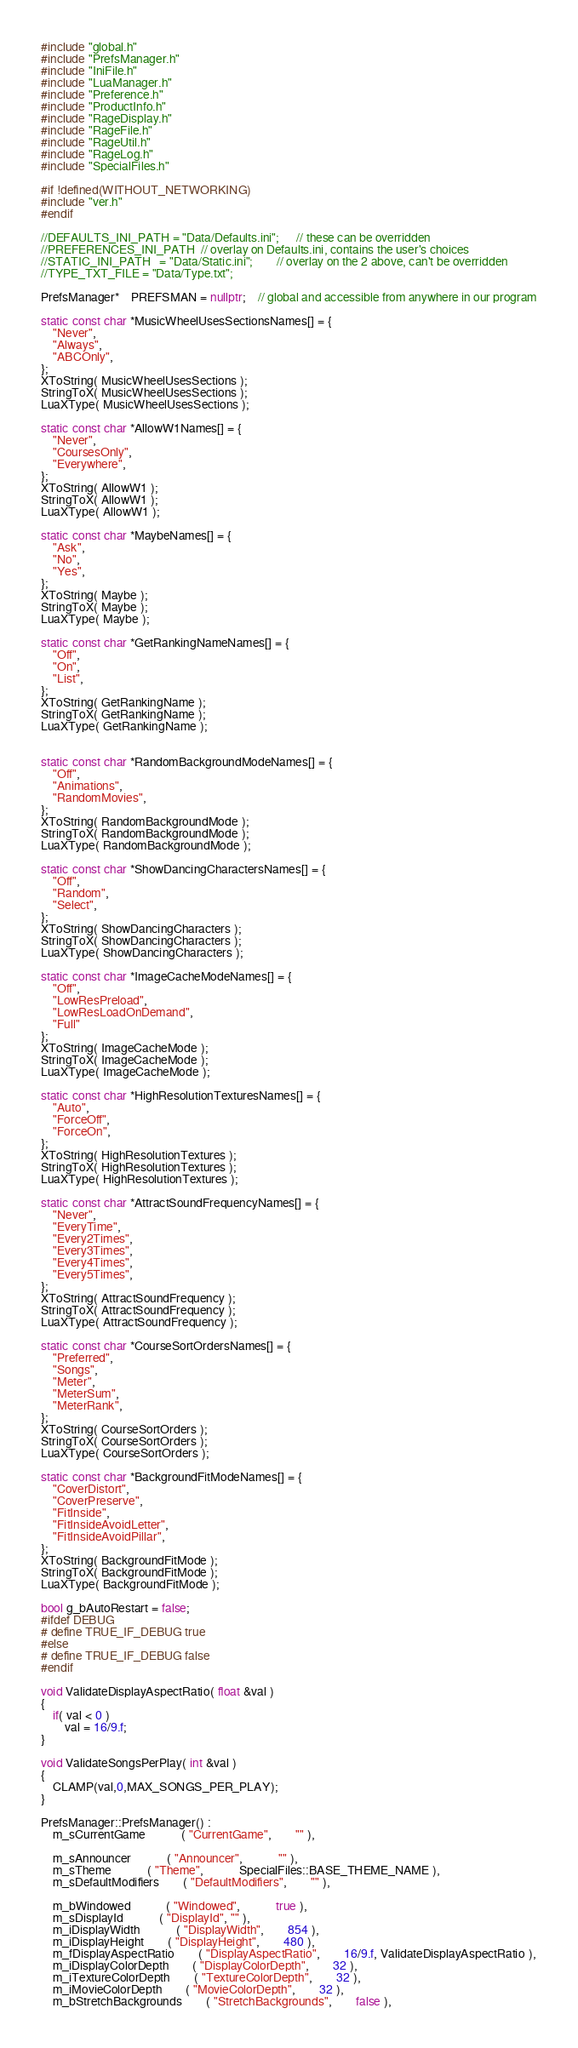Convert code to text. <code><loc_0><loc_0><loc_500><loc_500><_C++_>#include "global.h"
#include "PrefsManager.h"
#include "IniFile.h"
#include "LuaManager.h"
#include "Preference.h"
#include "ProductInfo.h"
#include "RageDisplay.h"
#include "RageFile.h"
#include "RageUtil.h"
#include "RageLog.h"
#include "SpecialFiles.h"

#if !defined(WITHOUT_NETWORKING)
#include "ver.h"
#endif

//DEFAULTS_INI_PATH	= "Data/Defaults.ini";		// these can be overridden
//PREFERENCES_INI_PATH	// overlay on Defaults.ini, contains the user's choices
//STATIC_INI_PATH	= "Data/Static.ini";		// overlay on the 2 above, can't be overridden
//TYPE_TXT_FILE	= "Data/Type.txt";

PrefsManager*	PREFSMAN = nullptr;	// global and accessible from anywhere in our program

static const char *MusicWheelUsesSectionsNames[] = {
	"Never",
	"Always",
	"ABCOnly",
};
XToString( MusicWheelUsesSections );
StringToX( MusicWheelUsesSections );
LuaXType( MusicWheelUsesSections );

static const char *AllowW1Names[] = {
	"Never",
	"CoursesOnly",
	"Everywhere",
};
XToString( AllowW1 );
StringToX( AllowW1 );
LuaXType( AllowW1 );

static const char *MaybeNames[] = {
	"Ask",
	"No",
	"Yes",
};
XToString( Maybe );
StringToX( Maybe );
LuaXType( Maybe );

static const char *GetRankingNameNames[] = {
	"Off",
	"On",
	"List",
};
XToString( GetRankingName );
StringToX( GetRankingName );
LuaXType( GetRankingName );


static const char *RandomBackgroundModeNames[] = {
	"Off",
	"Animations",
	"RandomMovies",
};
XToString( RandomBackgroundMode );
StringToX( RandomBackgroundMode );
LuaXType( RandomBackgroundMode );

static const char *ShowDancingCharactersNames[] = {
	"Off",
	"Random",
	"Select",
};
XToString( ShowDancingCharacters );
StringToX( ShowDancingCharacters );
LuaXType( ShowDancingCharacters );

static const char *ImageCacheModeNames[] = {
	"Off",
	"LowResPreload",
	"LowResLoadOnDemand",
	"Full"
};
XToString( ImageCacheMode );
StringToX( ImageCacheMode );
LuaXType( ImageCacheMode );

static const char *HighResolutionTexturesNames[] = {
	"Auto",
	"ForceOff",
	"ForceOn",
};
XToString( HighResolutionTextures );
StringToX( HighResolutionTextures );
LuaXType( HighResolutionTextures );

static const char *AttractSoundFrequencyNames[] = {
	"Never",
	"EveryTime",
	"Every2Times",
	"Every3Times",
	"Every4Times",
	"Every5Times",
};
XToString( AttractSoundFrequency );
StringToX( AttractSoundFrequency );
LuaXType( AttractSoundFrequency );

static const char *CourseSortOrdersNames[] = {
	"Preferred",
	"Songs",
	"Meter",
	"MeterSum",
	"MeterRank",
};
XToString( CourseSortOrders );
StringToX( CourseSortOrders );
LuaXType( CourseSortOrders );

static const char *BackgroundFitModeNames[] = {
	"CoverDistort",
	"CoverPreserve",
	"FitInside",
	"FitInsideAvoidLetter",
	"FitInsideAvoidPillar",
};
XToString( BackgroundFitMode );
StringToX( BackgroundFitMode );
LuaXType( BackgroundFitMode );

bool g_bAutoRestart = false;
#ifdef DEBUG
# define TRUE_IF_DEBUG true
#else
# define TRUE_IF_DEBUG false
#endif

void ValidateDisplayAspectRatio( float &val )
{
	if( val < 0 )
		val = 16/9.f;
}

void ValidateSongsPerPlay( int &val )
{
	CLAMP(val,0,MAX_SONGS_PER_PLAY);
}

PrefsManager::PrefsManager() :
	m_sCurrentGame			( "CurrentGame",		"" ),

	m_sAnnouncer			( "Announcer",			"" ),
	m_sTheme			( "Theme",			SpecialFiles::BASE_THEME_NAME ),
	m_sDefaultModifiers		( "DefaultModifiers",		"" ),

	m_bWindowed			( "Windowed",			true ),
	m_sDisplayId			( "DisplayId", "" ),
	m_iDisplayWidth			( "DisplayWidth",		854 ),
	m_iDisplayHeight		( "DisplayHeight",		480 ),
	m_fDisplayAspectRatio		( "DisplayAspectRatio",		16/9.f, ValidateDisplayAspectRatio ),
	m_iDisplayColorDepth		( "DisplayColorDepth",		32 ),
	m_iTextureColorDepth		( "TextureColorDepth",		32 ),
	m_iMovieColorDepth		( "MovieColorDepth",		32 ),
	m_bStretchBackgrounds		( "StretchBackgrounds",		false ),</code> 